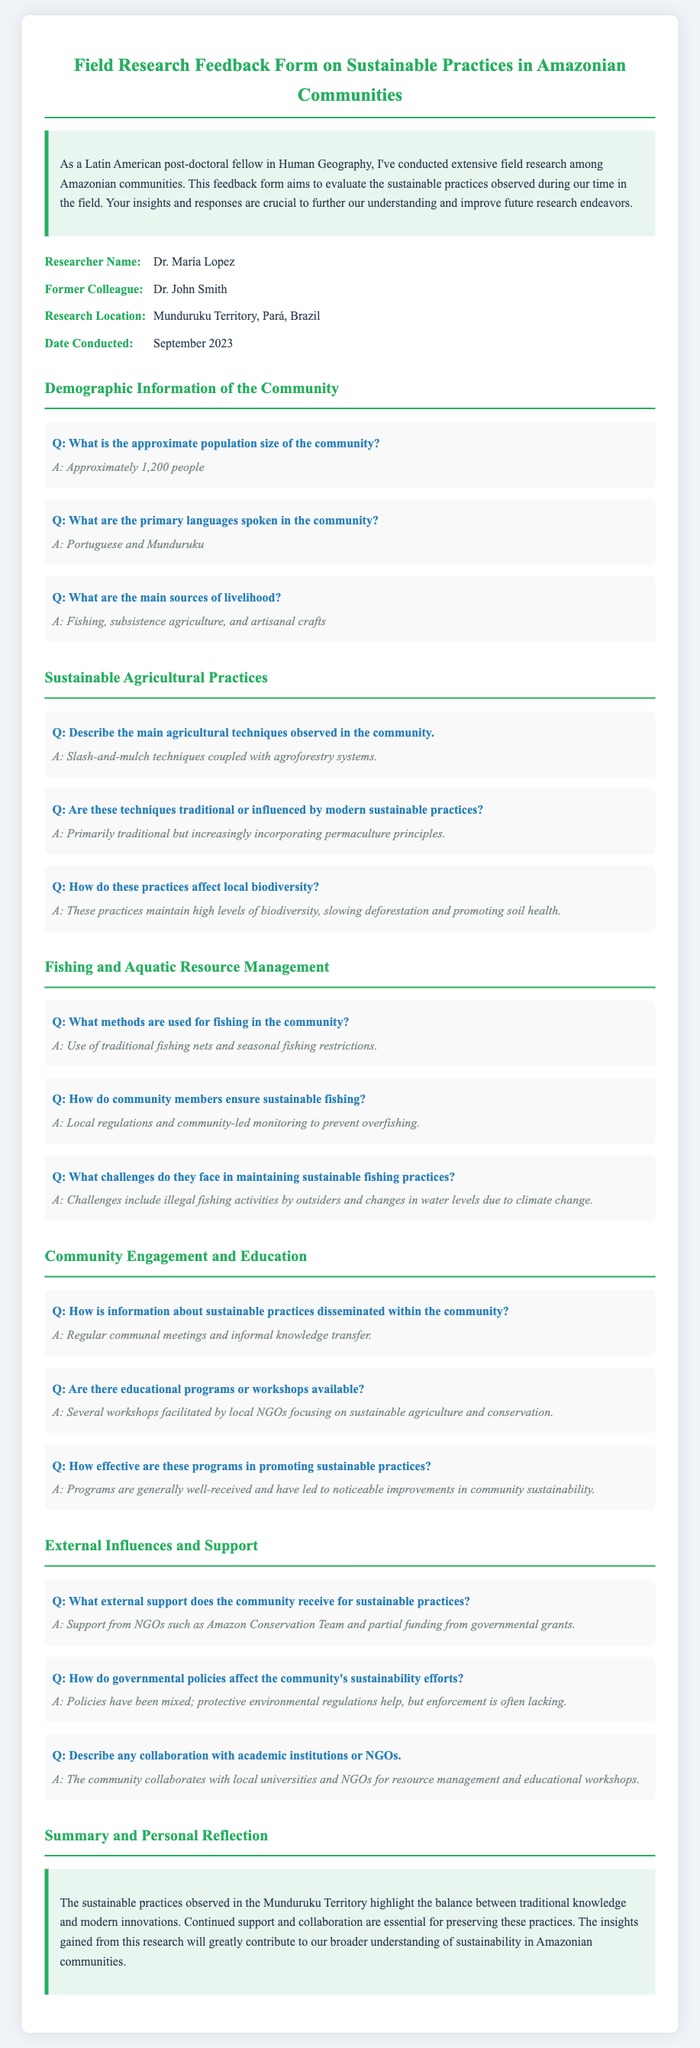What is the approximate population size of the community? The population size is provided specifically in the demographic section of the document, which states it is approximately 1,200 people.
Answer: Approximately 1,200 people What are the primary languages spoken in the community? The document explicitly lists the main languages in the community, which are Portuguese and Munduruku.
Answer: Portuguese and Munduruku What are the main sources of livelihood in the community? The document details the primary livelihood sources in the community under the demographic section: fishing, subsistence agriculture, and artisanal crafts.
Answer: Fishing, subsistence agriculture, and artisanal crafts What fishing methods are used in the community? The methods mentioned in the section about fishing include the use of traditional fishing nets and seasonal fishing restrictions.
Answer: Traditional fishing nets and seasonal fishing restrictions How does the community ensure sustainable fishing? The document outlines that community members use local regulations and community-led monitoring to prevent overfishing as a sustainable practice.
Answer: Local regulations and community-led monitoring What external support does the community receive? The document notes that the community receives support from NGOs like the Amazon Conservation Team and some governmental grants.
Answer: Support from NGOs and governmental grants What agricultural techniques are observed in the community? The agricultural practices described in the document mention slash-and-mulch techniques coupled with agroforestry systems.
Answer: Slash-and-mulch techniques and agroforestry systems How effective are the educational programs in promoting sustainable practices? The document indicates that the programs are generally well-received and have led to noticeable improvements in community sustainability.
Answer: Generally well-received and noticeable improvements What challenges exist in maintaining sustainable fishing practices? The challenges mentioned in the document include illegal fishing activities by outsiders and changes in water levels due to climate change.
Answer: Illegal fishing and climate change What is the research location stated in the document? The document specifies that the research location was in Munduruku Territory, Pará, Brazil.
Answer: Munduruku Territory, Pará, Brazil 